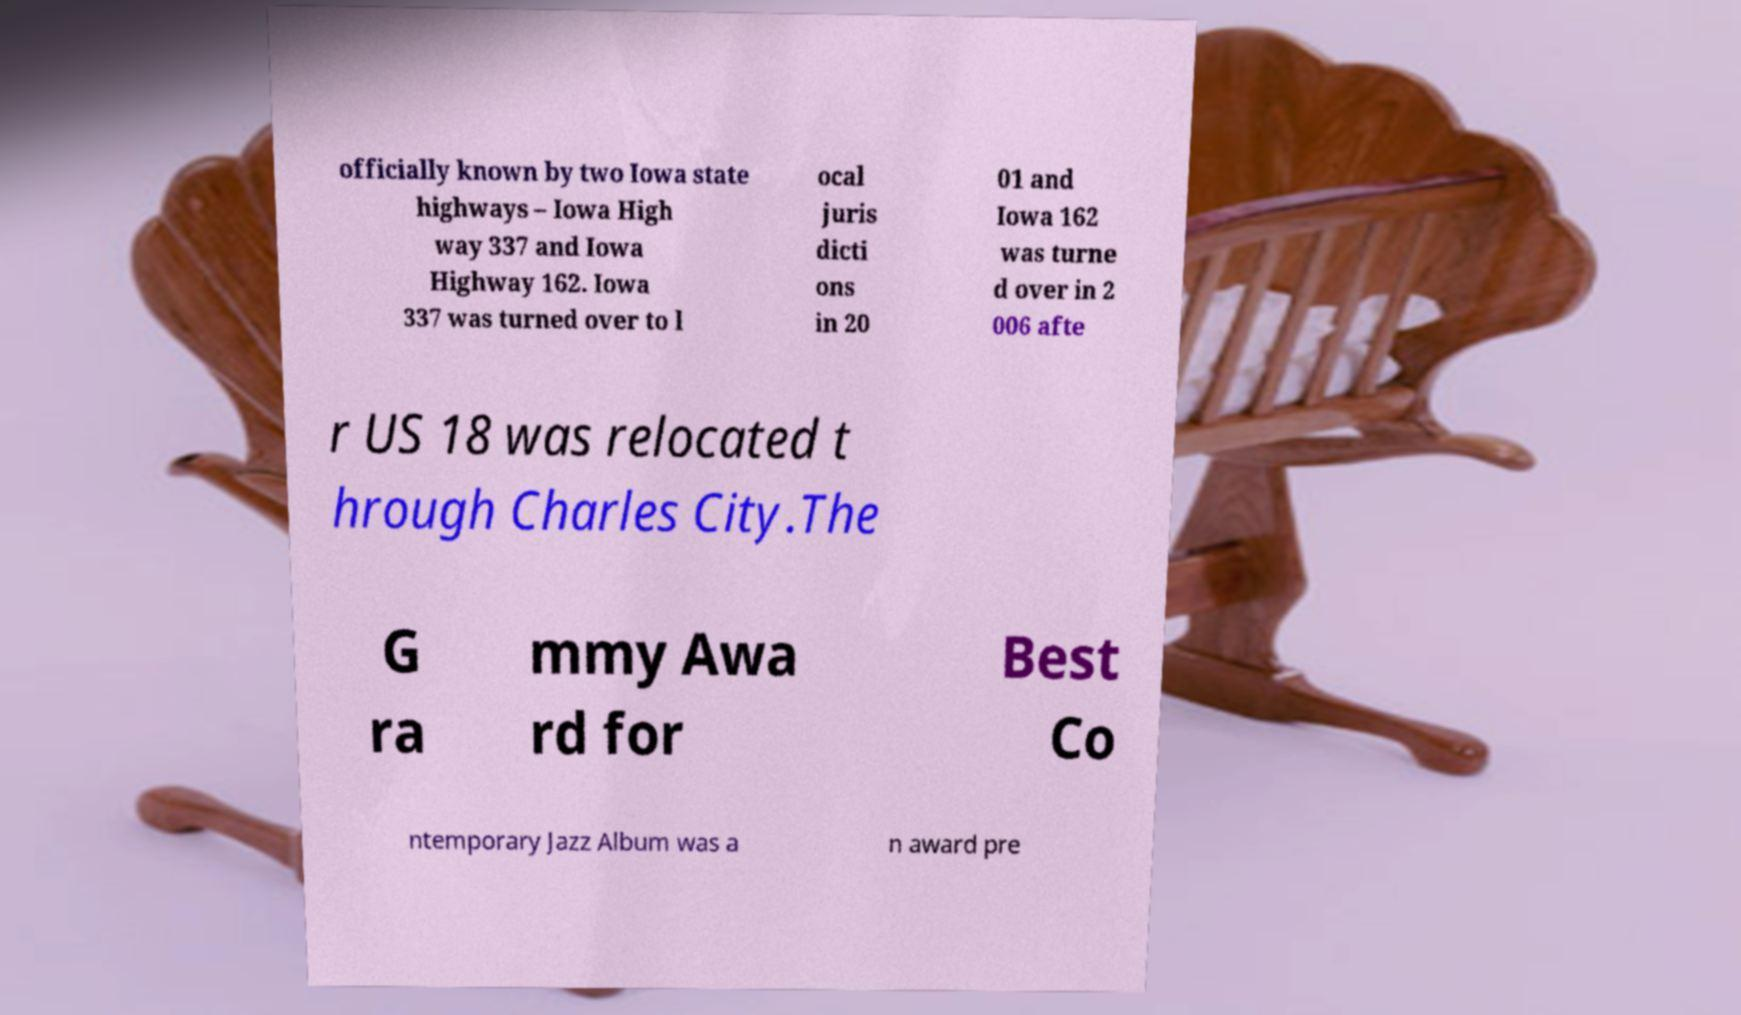Can you accurately transcribe the text from the provided image for me? officially known by two Iowa state highways – Iowa High way 337 and Iowa Highway 162. Iowa 337 was turned over to l ocal juris dicti ons in 20 01 and Iowa 162 was turne d over in 2 006 afte r US 18 was relocated t hrough Charles City.The G ra mmy Awa rd for Best Co ntemporary Jazz Album was a n award pre 